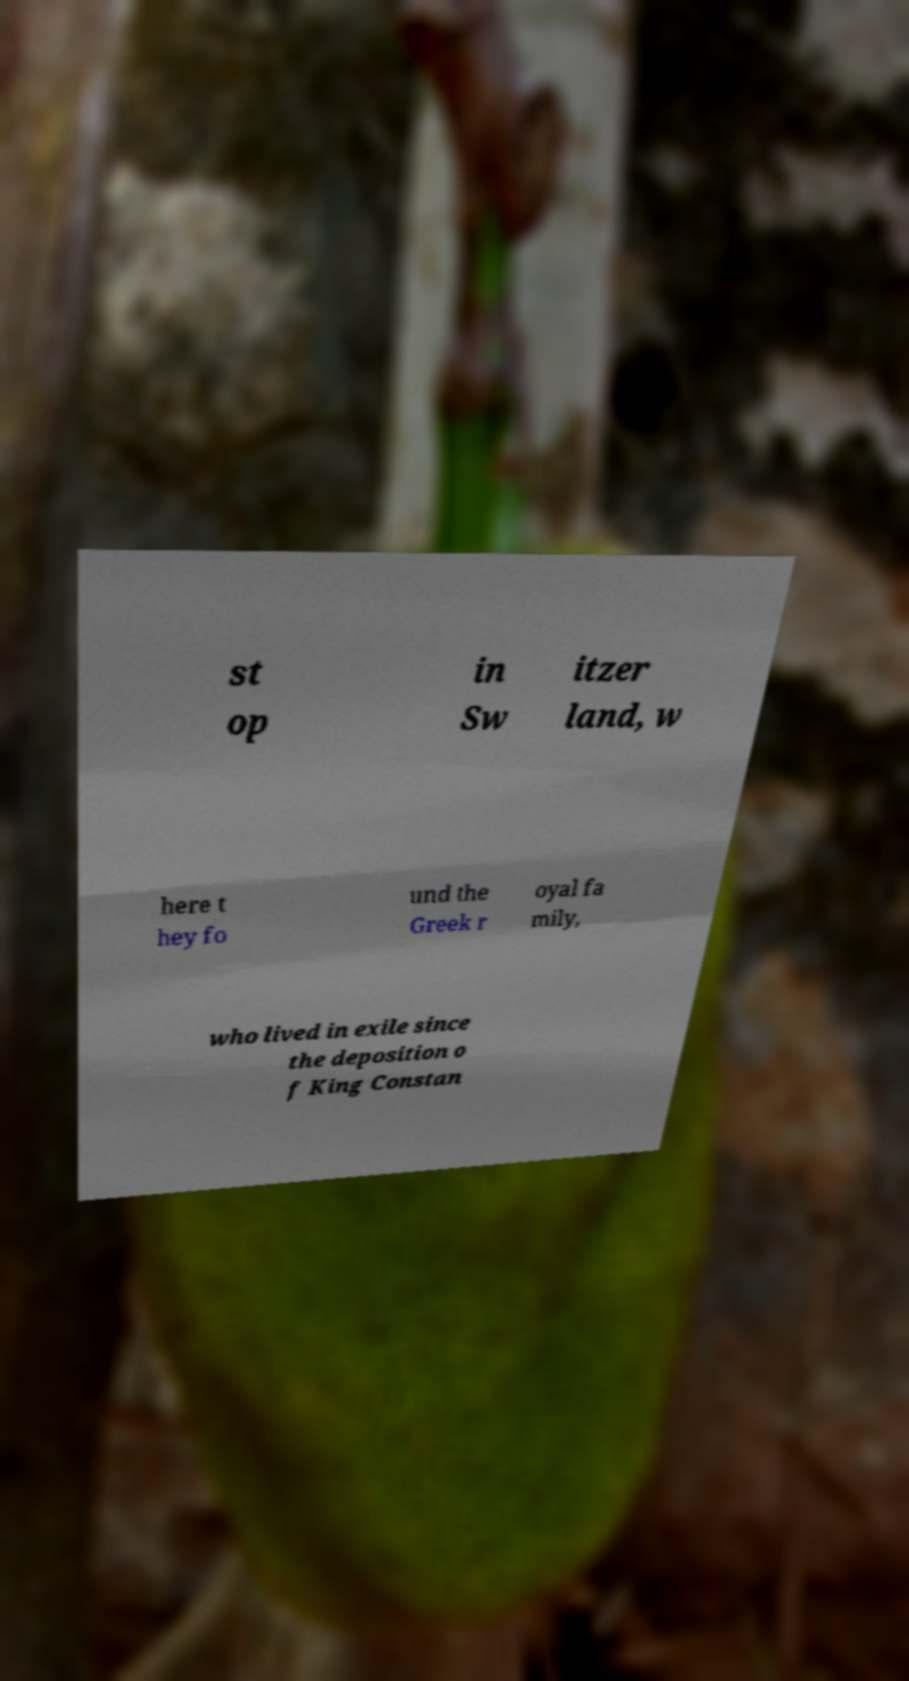Could you assist in decoding the text presented in this image and type it out clearly? st op in Sw itzer land, w here t hey fo und the Greek r oyal fa mily, who lived in exile since the deposition o f King Constan 